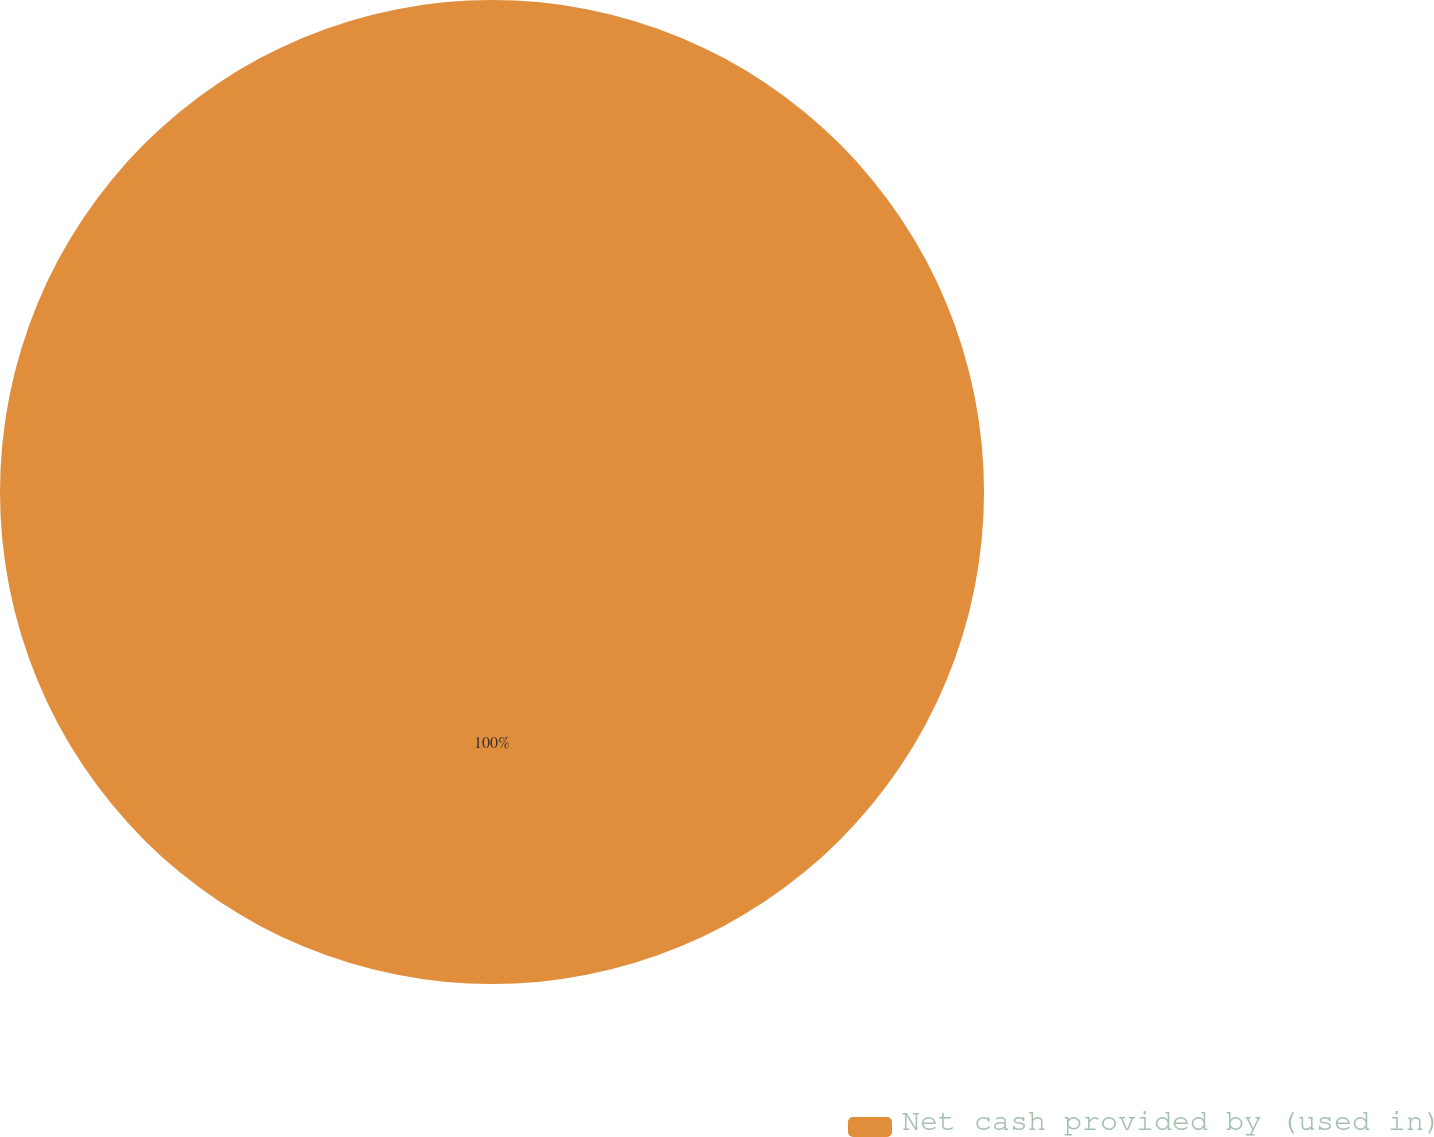Convert chart to OTSL. <chart><loc_0><loc_0><loc_500><loc_500><pie_chart><fcel>Net cash provided by (used in)<nl><fcel>100.0%<nl></chart> 